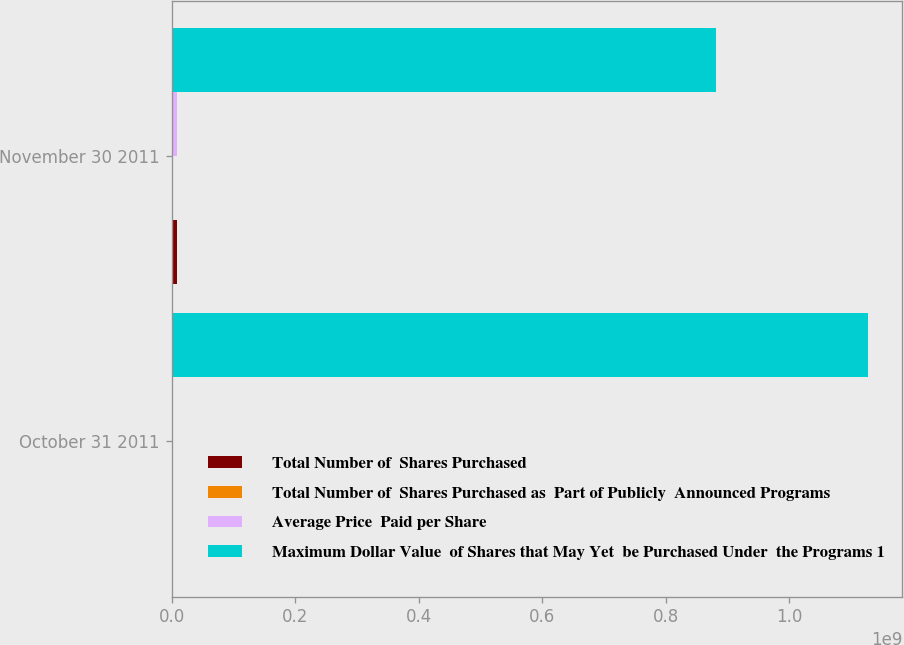Convert chart to OTSL. <chart><loc_0><loc_0><loc_500><loc_500><stacked_bar_chart><ecel><fcel>October 31 2011<fcel>November 30 2011<nl><fcel>Total Number of  Shares Purchased<fcel>117000<fcel>7.883e+06<nl><fcel>Total Number of  Shares Purchased as  Part of Publicly  Announced Programs<fcel>30.98<fcel>31.22<nl><fcel>Average Price  Paid per Share<fcel>117000<fcel>7.883e+06<nl><fcel>Maximum Dollar Value  of Shares that May Yet  be Purchased Under  the Programs 1<fcel>1.12659e+09<fcel>8.80522e+08<nl></chart> 